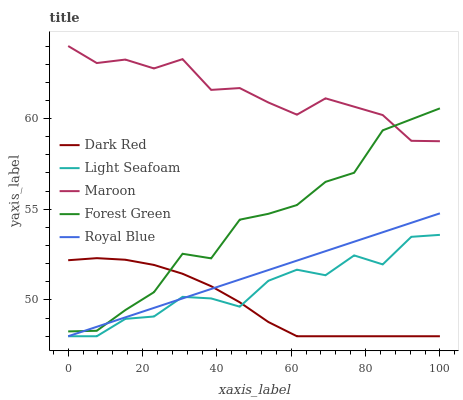Does Dark Red have the minimum area under the curve?
Answer yes or no. Yes. Does Maroon have the maximum area under the curve?
Answer yes or no. Yes. Does Forest Green have the minimum area under the curve?
Answer yes or no. No. Does Forest Green have the maximum area under the curve?
Answer yes or no. No. Is Royal Blue the smoothest?
Answer yes or no. Yes. Is Light Seafoam the roughest?
Answer yes or no. Yes. Is Forest Green the smoothest?
Answer yes or no. No. Is Forest Green the roughest?
Answer yes or no. No. Does Dark Red have the lowest value?
Answer yes or no. Yes. Does Forest Green have the lowest value?
Answer yes or no. No. Does Maroon have the highest value?
Answer yes or no. Yes. Does Forest Green have the highest value?
Answer yes or no. No. Is Dark Red less than Maroon?
Answer yes or no. Yes. Is Maroon greater than Royal Blue?
Answer yes or no. Yes. Does Light Seafoam intersect Royal Blue?
Answer yes or no. Yes. Is Light Seafoam less than Royal Blue?
Answer yes or no. No. Is Light Seafoam greater than Royal Blue?
Answer yes or no. No. Does Dark Red intersect Maroon?
Answer yes or no. No. 